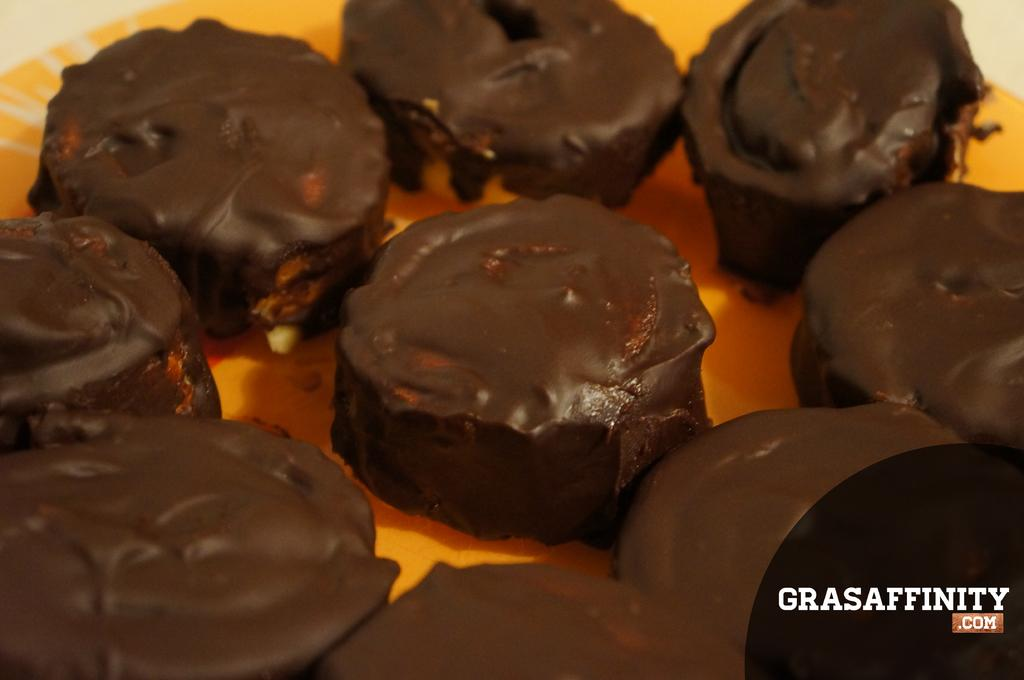What is on the plate that is visible in the image? The plate contains desserts. Where is the text located in the image? The text is in the bottom right corner of the image. What type of cabbage is being used as a garnish on the desserts in the image? There is no cabbage present in the image, as the plate contains desserts. 